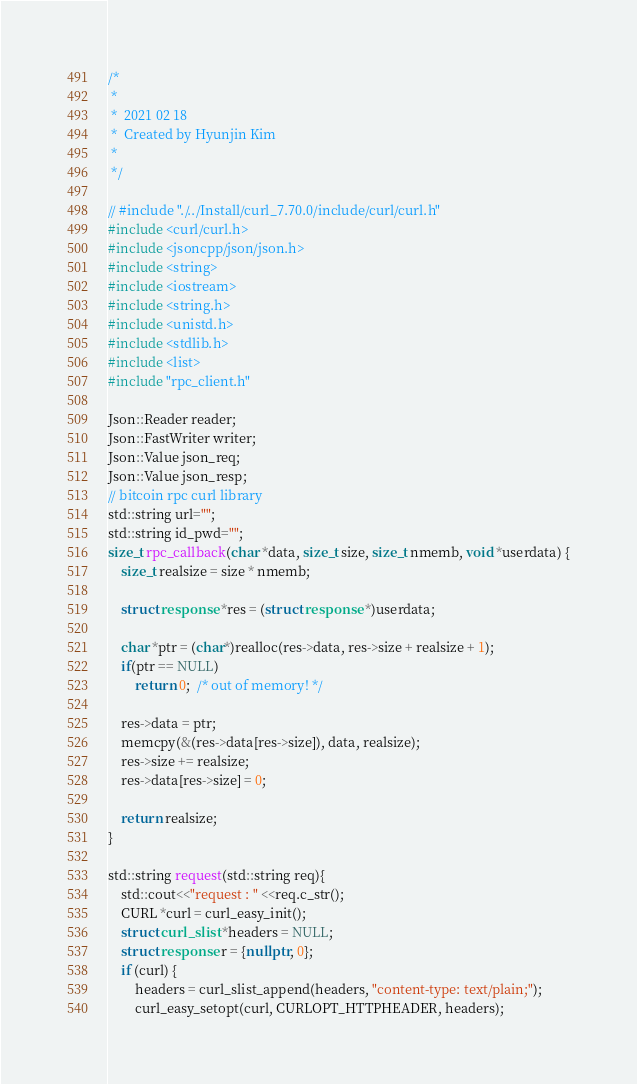<code> <loc_0><loc_0><loc_500><loc_500><_C++_>/*
 *
 *  2021 02 18
 *  Created by Hyunjin Kim
 *
 */

// #include "./../Install/curl_7.70.0/include/curl/curl.h"
#include <curl/curl.h>
#include <jsoncpp/json/json.h>
#include <string>
#include <iostream>
#include <string.h>
#include <unistd.h>
#include <stdlib.h>
#include <list>
#include "rpc_client.h"

Json::Reader reader;
Json::FastWriter writer;
Json::Value json_req;
Json::Value json_resp;
// bitcoin rpc curl library
std::string url="";
std::string id_pwd="";
size_t rpc_callback(char *data, size_t size, size_t nmemb, void *userdata) {
    size_t realsize = size * nmemb;

    struct response *res = (struct response *)userdata;

    char *ptr = (char*)realloc(res->data, res->size + realsize + 1);
    if(ptr == NULL)
        return 0;  /* out of memory! */

    res->data = ptr;
    memcpy(&(res->data[res->size]), data, realsize);
    res->size += realsize;
    res->data[res->size] = 0;

    return realsize;
}

std::string request(std::string req){
    std::cout<<"request : " <<req.c_str();
    CURL *curl = curl_easy_init();
    struct curl_slist *headers = NULL;
    struct response r = {nullptr, 0};
    if (curl) {
        headers = curl_slist_append(headers, "content-type: text/plain;");
        curl_easy_setopt(curl, CURLOPT_HTTPHEADER, headers);</code> 